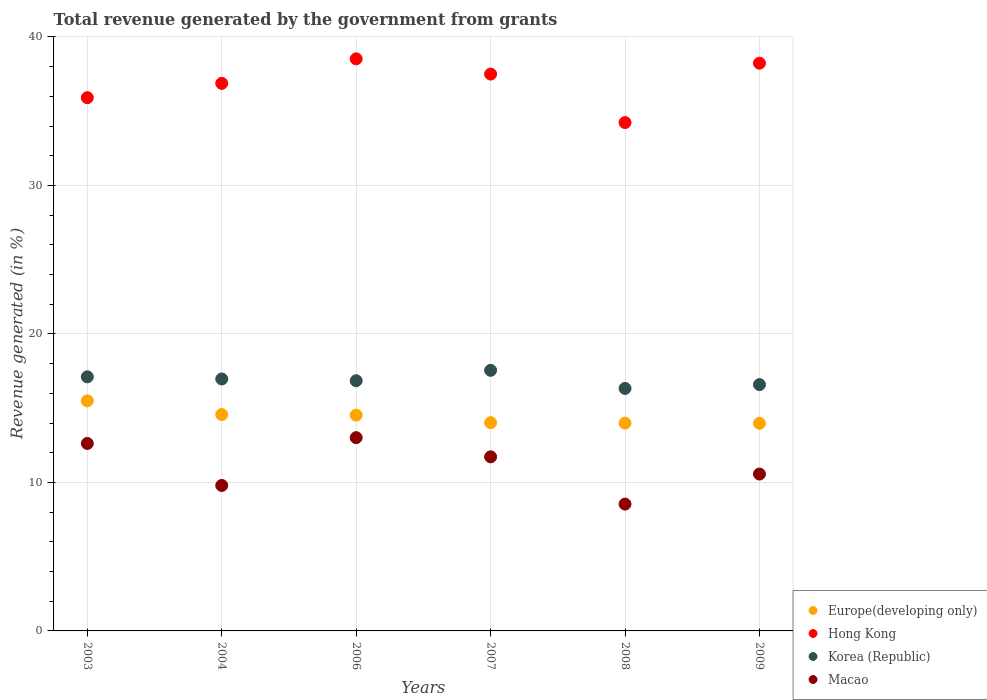What is the total revenue generated in Hong Kong in 2007?
Keep it short and to the point. 37.5. Across all years, what is the maximum total revenue generated in Europe(developing only)?
Your answer should be compact. 15.5. Across all years, what is the minimum total revenue generated in Korea (Republic)?
Ensure brevity in your answer.  16.33. In which year was the total revenue generated in Europe(developing only) maximum?
Your answer should be very brief. 2003. In which year was the total revenue generated in Europe(developing only) minimum?
Ensure brevity in your answer.  2009. What is the total total revenue generated in Europe(developing only) in the graph?
Your response must be concise. 86.59. What is the difference between the total revenue generated in Hong Kong in 2003 and that in 2008?
Keep it short and to the point. 1.67. What is the difference between the total revenue generated in Macao in 2004 and the total revenue generated in Europe(developing only) in 2009?
Your response must be concise. -4.19. What is the average total revenue generated in Macao per year?
Make the answer very short. 11.04. In the year 2009, what is the difference between the total revenue generated in Hong Kong and total revenue generated in Korea (Republic)?
Provide a succinct answer. 21.65. In how many years, is the total revenue generated in Macao greater than 12 %?
Offer a terse response. 2. What is the ratio of the total revenue generated in Korea (Republic) in 2004 to that in 2009?
Offer a terse response. 1.02. Is the total revenue generated in Europe(developing only) in 2003 less than that in 2004?
Offer a terse response. No. Is the difference between the total revenue generated in Hong Kong in 2003 and 2008 greater than the difference between the total revenue generated in Korea (Republic) in 2003 and 2008?
Offer a very short reply. Yes. What is the difference between the highest and the second highest total revenue generated in Europe(developing only)?
Your response must be concise. 0.93. What is the difference between the highest and the lowest total revenue generated in Europe(developing only)?
Keep it short and to the point. 1.51. In how many years, is the total revenue generated in Macao greater than the average total revenue generated in Macao taken over all years?
Make the answer very short. 3. Is the sum of the total revenue generated in Korea (Republic) in 2004 and 2007 greater than the maximum total revenue generated in Macao across all years?
Ensure brevity in your answer.  Yes. Is it the case that in every year, the sum of the total revenue generated in Macao and total revenue generated in Hong Kong  is greater than the total revenue generated in Korea (Republic)?
Keep it short and to the point. Yes. Does the total revenue generated in Hong Kong monotonically increase over the years?
Give a very brief answer. No. Is the total revenue generated in Hong Kong strictly greater than the total revenue generated in Europe(developing only) over the years?
Offer a terse response. Yes. Is the total revenue generated in Hong Kong strictly less than the total revenue generated in Europe(developing only) over the years?
Offer a terse response. No. How many dotlines are there?
Your response must be concise. 4. How many years are there in the graph?
Your answer should be very brief. 6. What is the difference between two consecutive major ticks on the Y-axis?
Provide a succinct answer. 10. Does the graph contain any zero values?
Offer a terse response. No. Does the graph contain grids?
Offer a very short reply. Yes. Where does the legend appear in the graph?
Offer a terse response. Bottom right. How many legend labels are there?
Offer a very short reply. 4. What is the title of the graph?
Your response must be concise. Total revenue generated by the government from grants. Does "Romania" appear as one of the legend labels in the graph?
Keep it short and to the point. No. What is the label or title of the X-axis?
Keep it short and to the point. Years. What is the label or title of the Y-axis?
Your answer should be compact. Revenue generated (in %). What is the Revenue generated (in %) in Europe(developing only) in 2003?
Provide a succinct answer. 15.5. What is the Revenue generated (in %) of Hong Kong in 2003?
Your response must be concise. 35.91. What is the Revenue generated (in %) of Korea (Republic) in 2003?
Provide a short and direct response. 17.11. What is the Revenue generated (in %) in Macao in 2003?
Make the answer very short. 12.62. What is the Revenue generated (in %) of Europe(developing only) in 2004?
Ensure brevity in your answer.  14.57. What is the Revenue generated (in %) of Hong Kong in 2004?
Provide a short and direct response. 36.87. What is the Revenue generated (in %) in Korea (Republic) in 2004?
Keep it short and to the point. 16.97. What is the Revenue generated (in %) in Macao in 2004?
Your answer should be compact. 9.8. What is the Revenue generated (in %) in Europe(developing only) in 2006?
Offer a terse response. 14.53. What is the Revenue generated (in %) of Hong Kong in 2006?
Offer a very short reply. 38.52. What is the Revenue generated (in %) in Korea (Republic) in 2006?
Ensure brevity in your answer.  16.85. What is the Revenue generated (in %) in Macao in 2006?
Your response must be concise. 13.02. What is the Revenue generated (in %) in Europe(developing only) in 2007?
Provide a short and direct response. 14.02. What is the Revenue generated (in %) in Hong Kong in 2007?
Keep it short and to the point. 37.5. What is the Revenue generated (in %) of Korea (Republic) in 2007?
Make the answer very short. 17.55. What is the Revenue generated (in %) in Macao in 2007?
Make the answer very short. 11.72. What is the Revenue generated (in %) of Europe(developing only) in 2008?
Offer a terse response. 13.99. What is the Revenue generated (in %) in Hong Kong in 2008?
Your response must be concise. 34.23. What is the Revenue generated (in %) of Korea (Republic) in 2008?
Give a very brief answer. 16.33. What is the Revenue generated (in %) in Macao in 2008?
Provide a succinct answer. 8.54. What is the Revenue generated (in %) in Europe(developing only) in 2009?
Your response must be concise. 13.98. What is the Revenue generated (in %) in Hong Kong in 2009?
Make the answer very short. 38.23. What is the Revenue generated (in %) of Korea (Republic) in 2009?
Provide a short and direct response. 16.59. What is the Revenue generated (in %) in Macao in 2009?
Offer a very short reply. 10.56. Across all years, what is the maximum Revenue generated (in %) in Europe(developing only)?
Offer a terse response. 15.5. Across all years, what is the maximum Revenue generated (in %) in Hong Kong?
Keep it short and to the point. 38.52. Across all years, what is the maximum Revenue generated (in %) in Korea (Republic)?
Provide a succinct answer. 17.55. Across all years, what is the maximum Revenue generated (in %) of Macao?
Offer a very short reply. 13.02. Across all years, what is the minimum Revenue generated (in %) of Europe(developing only)?
Offer a terse response. 13.98. Across all years, what is the minimum Revenue generated (in %) of Hong Kong?
Make the answer very short. 34.23. Across all years, what is the minimum Revenue generated (in %) of Korea (Republic)?
Give a very brief answer. 16.33. Across all years, what is the minimum Revenue generated (in %) of Macao?
Your response must be concise. 8.54. What is the total Revenue generated (in %) of Europe(developing only) in the graph?
Ensure brevity in your answer.  86.59. What is the total Revenue generated (in %) of Hong Kong in the graph?
Provide a succinct answer. 221.27. What is the total Revenue generated (in %) of Korea (Republic) in the graph?
Provide a succinct answer. 101.39. What is the total Revenue generated (in %) of Macao in the graph?
Your answer should be very brief. 66.26. What is the difference between the Revenue generated (in %) of Europe(developing only) in 2003 and that in 2004?
Offer a terse response. 0.93. What is the difference between the Revenue generated (in %) of Hong Kong in 2003 and that in 2004?
Give a very brief answer. -0.97. What is the difference between the Revenue generated (in %) of Korea (Republic) in 2003 and that in 2004?
Your answer should be compact. 0.14. What is the difference between the Revenue generated (in %) of Macao in 2003 and that in 2004?
Ensure brevity in your answer.  2.83. What is the difference between the Revenue generated (in %) in Europe(developing only) in 2003 and that in 2006?
Your answer should be very brief. 0.96. What is the difference between the Revenue generated (in %) in Hong Kong in 2003 and that in 2006?
Your answer should be compact. -2.62. What is the difference between the Revenue generated (in %) in Korea (Republic) in 2003 and that in 2006?
Provide a succinct answer. 0.26. What is the difference between the Revenue generated (in %) of Macao in 2003 and that in 2006?
Provide a short and direct response. -0.39. What is the difference between the Revenue generated (in %) of Europe(developing only) in 2003 and that in 2007?
Your response must be concise. 1.47. What is the difference between the Revenue generated (in %) of Hong Kong in 2003 and that in 2007?
Keep it short and to the point. -1.59. What is the difference between the Revenue generated (in %) of Korea (Republic) in 2003 and that in 2007?
Make the answer very short. -0.44. What is the difference between the Revenue generated (in %) of Macao in 2003 and that in 2007?
Ensure brevity in your answer.  0.9. What is the difference between the Revenue generated (in %) of Europe(developing only) in 2003 and that in 2008?
Your answer should be compact. 1.5. What is the difference between the Revenue generated (in %) of Hong Kong in 2003 and that in 2008?
Make the answer very short. 1.67. What is the difference between the Revenue generated (in %) in Korea (Republic) in 2003 and that in 2008?
Keep it short and to the point. 0.78. What is the difference between the Revenue generated (in %) of Macao in 2003 and that in 2008?
Ensure brevity in your answer.  4.08. What is the difference between the Revenue generated (in %) of Europe(developing only) in 2003 and that in 2009?
Make the answer very short. 1.51. What is the difference between the Revenue generated (in %) of Hong Kong in 2003 and that in 2009?
Your response must be concise. -2.32. What is the difference between the Revenue generated (in %) of Korea (Republic) in 2003 and that in 2009?
Ensure brevity in your answer.  0.52. What is the difference between the Revenue generated (in %) of Macao in 2003 and that in 2009?
Give a very brief answer. 2.06. What is the difference between the Revenue generated (in %) in Europe(developing only) in 2004 and that in 2006?
Your answer should be very brief. 0.04. What is the difference between the Revenue generated (in %) in Hong Kong in 2004 and that in 2006?
Offer a very short reply. -1.65. What is the difference between the Revenue generated (in %) in Korea (Republic) in 2004 and that in 2006?
Your answer should be compact. 0.12. What is the difference between the Revenue generated (in %) in Macao in 2004 and that in 2006?
Offer a very short reply. -3.22. What is the difference between the Revenue generated (in %) of Europe(developing only) in 2004 and that in 2007?
Offer a terse response. 0.54. What is the difference between the Revenue generated (in %) of Hong Kong in 2004 and that in 2007?
Your answer should be compact. -0.63. What is the difference between the Revenue generated (in %) of Korea (Republic) in 2004 and that in 2007?
Keep it short and to the point. -0.58. What is the difference between the Revenue generated (in %) of Macao in 2004 and that in 2007?
Ensure brevity in your answer.  -1.93. What is the difference between the Revenue generated (in %) in Europe(developing only) in 2004 and that in 2008?
Keep it short and to the point. 0.58. What is the difference between the Revenue generated (in %) of Hong Kong in 2004 and that in 2008?
Offer a very short reply. 2.64. What is the difference between the Revenue generated (in %) in Korea (Republic) in 2004 and that in 2008?
Your response must be concise. 0.64. What is the difference between the Revenue generated (in %) in Macao in 2004 and that in 2008?
Your answer should be very brief. 1.26. What is the difference between the Revenue generated (in %) in Europe(developing only) in 2004 and that in 2009?
Give a very brief answer. 0.59. What is the difference between the Revenue generated (in %) of Hong Kong in 2004 and that in 2009?
Provide a succinct answer. -1.36. What is the difference between the Revenue generated (in %) in Korea (Republic) in 2004 and that in 2009?
Offer a terse response. 0.38. What is the difference between the Revenue generated (in %) in Macao in 2004 and that in 2009?
Make the answer very short. -0.77. What is the difference between the Revenue generated (in %) of Europe(developing only) in 2006 and that in 2007?
Provide a short and direct response. 0.51. What is the difference between the Revenue generated (in %) in Hong Kong in 2006 and that in 2007?
Your response must be concise. 1.03. What is the difference between the Revenue generated (in %) of Korea (Republic) in 2006 and that in 2007?
Make the answer very short. -0.7. What is the difference between the Revenue generated (in %) of Macao in 2006 and that in 2007?
Provide a succinct answer. 1.29. What is the difference between the Revenue generated (in %) of Europe(developing only) in 2006 and that in 2008?
Provide a short and direct response. 0.54. What is the difference between the Revenue generated (in %) in Hong Kong in 2006 and that in 2008?
Offer a terse response. 4.29. What is the difference between the Revenue generated (in %) of Korea (Republic) in 2006 and that in 2008?
Make the answer very short. 0.52. What is the difference between the Revenue generated (in %) of Macao in 2006 and that in 2008?
Ensure brevity in your answer.  4.47. What is the difference between the Revenue generated (in %) in Europe(developing only) in 2006 and that in 2009?
Offer a very short reply. 0.55. What is the difference between the Revenue generated (in %) in Hong Kong in 2006 and that in 2009?
Ensure brevity in your answer.  0.29. What is the difference between the Revenue generated (in %) in Korea (Republic) in 2006 and that in 2009?
Offer a terse response. 0.26. What is the difference between the Revenue generated (in %) of Macao in 2006 and that in 2009?
Keep it short and to the point. 2.45. What is the difference between the Revenue generated (in %) of Europe(developing only) in 2007 and that in 2008?
Your answer should be compact. 0.03. What is the difference between the Revenue generated (in %) of Hong Kong in 2007 and that in 2008?
Your response must be concise. 3.27. What is the difference between the Revenue generated (in %) of Korea (Republic) in 2007 and that in 2008?
Make the answer very short. 1.22. What is the difference between the Revenue generated (in %) of Macao in 2007 and that in 2008?
Make the answer very short. 3.18. What is the difference between the Revenue generated (in %) of Europe(developing only) in 2007 and that in 2009?
Offer a terse response. 0.04. What is the difference between the Revenue generated (in %) in Hong Kong in 2007 and that in 2009?
Your answer should be compact. -0.73. What is the difference between the Revenue generated (in %) in Korea (Republic) in 2007 and that in 2009?
Ensure brevity in your answer.  0.96. What is the difference between the Revenue generated (in %) in Macao in 2007 and that in 2009?
Provide a short and direct response. 1.16. What is the difference between the Revenue generated (in %) of Europe(developing only) in 2008 and that in 2009?
Make the answer very short. 0.01. What is the difference between the Revenue generated (in %) of Hong Kong in 2008 and that in 2009?
Make the answer very short. -4. What is the difference between the Revenue generated (in %) in Korea (Republic) in 2008 and that in 2009?
Provide a succinct answer. -0.26. What is the difference between the Revenue generated (in %) of Macao in 2008 and that in 2009?
Your answer should be very brief. -2.02. What is the difference between the Revenue generated (in %) of Europe(developing only) in 2003 and the Revenue generated (in %) of Hong Kong in 2004?
Your response must be concise. -21.38. What is the difference between the Revenue generated (in %) in Europe(developing only) in 2003 and the Revenue generated (in %) in Korea (Republic) in 2004?
Offer a terse response. -1.47. What is the difference between the Revenue generated (in %) of Europe(developing only) in 2003 and the Revenue generated (in %) of Macao in 2004?
Offer a very short reply. 5.7. What is the difference between the Revenue generated (in %) of Hong Kong in 2003 and the Revenue generated (in %) of Korea (Republic) in 2004?
Ensure brevity in your answer.  18.94. What is the difference between the Revenue generated (in %) of Hong Kong in 2003 and the Revenue generated (in %) of Macao in 2004?
Provide a short and direct response. 26.11. What is the difference between the Revenue generated (in %) of Korea (Republic) in 2003 and the Revenue generated (in %) of Macao in 2004?
Your response must be concise. 7.31. What is the difference between the Revenue generated (in %) of Europe(developing only) in 2003 and the Revenue generated (in %) of Hong Kong in 2006?
Offer a terse response. -23.03. What is the difference between the Revenue generated (in %) in Europe(developing only) in 2003 and the Revenue generated (in %) in Korea (Republic) in 2006?
Your answer should be very brief. -1.35. What is the difference between the Revenue generated (in %) in Europe(developing only) in 2003 and the Revenue generated (in %) in Macao in 2006?
Give a very brief answer. 2.48. What is the difference between the Revenue generated (in %) in Hong Kong in 2003 and the Revenue generated (in %) in Korea (Republic) in 2006?
Offer a terse response. 19.06. What is the difference between the Revenue generated (in %) of Hong Kong in 2003 and the Revenue generated (in %) of Macao in 2006?
Offer a terse response. 22.89. What is the difference between the Revenue generated (in %) in Korea (Republic) in 2003 and the Revenue generated (in %) in Macao in 2006?
Offer a terse response. 4.1. What is the difference between the Revenue generated (in %) of Europe(developing only) in 2003 and the Revenue generated (in %) of Hong Kong in 2007?
Your answer should be very brief. -22. What is the difference between the Revenue generated (in %) of Europe(developing only) in 2003 and the Revenue generated (in %) of Korea (Republic) in 2007?
Your response must be concise. -2.05. What is the difference between the Revenue generated (in %) of Europe(developing only) in 2003 and the Revenue generated (in %) of Macao in 2007?
Keep it short and to the point. 3.77. What is the difference between the Revenue generated (in %) of Hong Kong in 2003 and the Revenue generated (in %) of Korea (Republic) in 2007?
Your answer should be compact. 18.36. What is the difference between the Revenue generated (in %) in Hong Kong in 2003 and the Revenue generated (in %) in Macao in 2007?
Offer a very short reply. 24.18. What is the difference between the Revenue generated (in %) in Korea (Republic) in 2003 and the Revenue generated (in %) in Macao in 2007?
Your answer should be compact. 5.39. What is the difference between the Revenue generated (in %) in Europe(developing only) in 2003 and the Revenue generated (in %) in Hong Kong in 2008?
Provide a succinct answer. -18.74. What is the difference between the Revenue generated (in %) of Europe(developing only) in 2003 and the Revenue generated (in %) of Korea (Republic) in 2008?
Offer a very short reply. -0.83. What is the difference between the Revenue generated (in %) in Europe(developing only) in 2003 and the Revenue generated (in %) in Macao in 2008?
Offer a terse response. 6.95. What is the difference between the Revenue generated (in %) of Hong Kong in 2003 and the Revenue generated (in %) of Korea (Republic) in 2008?
Your response must be concise. 19.58. What is the difference between the Revenue generated (in %) of Hong Kong in 2003 and the Revenue generated (in %) of Macao in 2008?
Offer a terse response. 27.37. What is the difference between the Revenue generated (in %) of Korea (Republic) in 2003 and the Revenue generated (in %) of Macao in 2008?
Provide a succinct answer. 8.57. What is the difference between the Revenue generated (in %) in Europe(developing only) in 2003 and the Revenue generated (in %) in Hong Kong in 2009?
Keep it short and to the point. -22.74. What is the difference between the Revenue generated (in %) of Europe(developing only) in 2003 and the Revenue generated (in %) of Korea (Republic) in 2009?
Give a very brief answer. -1.09. What is the difference between the Revenue generated (in %) of Europe(developing only) in 2003 and the Revenue generated (in %) of Macao in 2009?
Give a very brief answer. 4.93. What is the difference between the Revenue generated (in %) of Hong Kong in 2003 and the Revenue generated (in %) of Korea (Republic) in 2009?
Provide a short and direct response. 19.32. What is the difference between the Revenue generated (in %) in Hong Kong in 2003 and the Revenue generated (in %) in Macao in 2009?
Make the answer very short. 25.34. What is the difference between the Revenue generated (in %) in Korea (Republic) in 2003 and the Revenue generated (in %) in Macao in 2009?
Offer a very short reply. 6.55. What is the difference between the Revenue generated (in %) of Europe(developing only) in 2004 and the Revenue generated (in %) of Hong Kong in 2006?
Make the answer very short. -23.96. What is the difference between the Revenue generated (in %) of Europe(developing only) in 2004 and the Revenue generated (in %) of Korea (Republic) in 2006?
Your answer should be very brief. -2.28. What is the difference between the Revenue generated (in %) in Europe(developing only) in 2004 and the Revenue generated (in %) in Macao in 2006?
Offer a terse response. 1.55. What is the difference between the Revenue generated (in %) of Hong Kong in 2004 and the Revenue generated (in %) of Korea (Republic) in 2006?
Offer a very short reply. 20.03. What is the difference between the Revenue generated (in %) of Hong Kong in 2004 and the Revenue generated (in %) of Macao in 2006?
Ensure brevity in your answer.  23.86. What is the difference between the Revenue generated (in %) in Korea (Republic) in 2004 and the Revenue generated (in %) in Macao in 2006?
Provide a succinct answer. 3.95. What is the difference between the Revenue generated (in %) in Europe(developing only) in 2004 and the Revenue generated (in %) in Hong Kong in 2007?
Your response must be concise. -22.93. What is the difference between the Revenue generated (in %) in Europe(developing only) in 2004 and the Revenue generated (in %) in Korea (Republic) in 2007?
Provide a succinct answer. -2.98. What is the difference between the Revenue generated (in %) in Europe(developing only) in 2004 and the Revenue generated (in %) in Macao in 2007?
Give a very brief answer. 2.84. What is the difference between the Revenue generated (in %) of Hong Kong in 2004 and the Revenue generated (in %) of Korea (Republic) in 2007?
Provide a short and direct response. 19.32. What is the difference between the Revenue generated (in %) of Hong Kong in 2004 and the Revenue generated (in %) of Macao in 2007?
Provide a succinct answer. 25.15. What is the difference between the Revenue generated (in %) in Korea (Republic) in 2004 and the Revenue generated (in %) in Macao in 2007?
Keep it short and to the point. 5.24. What is the difference between the Revenue generated (in %) in Europe(developing only) in 2004 and the Revenue generated (in %) in Hong Kong in 2008?
Offer a terse response. -19.67. What is the difference between the Revenue generated (in %) of Europe(developing only) in 2004 and the Revenue generated (in %) of Korea (Republic) in 2008?
Your answer should be very brief. -1.76. What is the difference between the Revenue generated (in %) in Europe(developing only) in 2004 and the Revenue generated (in %) in Macao in 2008?
Your answer should be very brief. 6.03. What is the difference between the Revenue generated (in %) in Hong Kong in 2004 and the Revenue generated (in %) in Korea (Republic) in 2008?
Provide a short and direct response. 20.54. What is the difference between the Revenue generated (in %) in Hong Kong in 2004 and the Revenue generated (in %) in Macao in 2008?
Provide a short and direct response. 28.33. What is the difference between the Revenue generated (in %) of Korea (Republic) in 2004 and the Revenue generated (in %) of Macao in 2008?
Offer a very short reply. 8.43. What is the difference between the Revenue generated (in %) in Europe(developing only) in 2004 and the Revenue generated (in %) in Hong Kong in 2009?
Your answer should be very brief. -23.66. What is the difference between the Revenue generated (in %) in Europe(developing only) in 2004 and the Revenue generated (in %) in Korea (Republic) in 2009?
Ensure brevity in your answer.  -2.02. What is the difference between the Revenue generated (in %) of Europe(developing only) in 2004 and the Revenue generated (in %) of Macao in 2009?
Give a very brief answer. 4. What is the difference between the Revenue generated (in %) of Hong Kong in 2004 and the Revenue generated (in %) of Korea (Republic) in 2009?
Your answer should be very brief. 20.29. What is the difference between the Revenue generated (in %) in Hong Kong in 2004 and the Revenue generated (in %) in Macao in 2009?
Make the answer very short. 26.31. What is the difference between the Revenue generated (in %) of Korea (Republic) in 2004 and the Revenue generated (in %) of Macao in 2009?
Provide a succinct answer. 6.4. What is the difference between the Revenue generated (in %) of Europe(developing only) in 2006 and the Revenue generated (in %) of Hong Kong in 2007?
Keep it short and to the point. -22.97. What is the difference between the Revenue generated (in %) in Europe(developing only) in 2006 and the Revenue generated (in %) in Korea (Republic) in 2007?
Provide a short and direct response. -3.02. What is the difference between the Revenue generated (in %) of Europe(developing only) in 2006 and the Revenue generated (in %) of Macao in 2007?
Offer a terse response. 2.81. What is the difference between the Revenue generated (in %) in Hong Kong in 2006 and the Revenue generated (in %) in Korea (Republic) in 2007?
Keep it short and to the point. 20.98. What is the difference between the Revenue generated (in %) of Hong Kong in 2006 and the Revenue generated (in %) of Macao in 2007?
Provide a succinct answer. 26.8. What is the difference between the Revenue generated (in %) of Korea (Republic) in 2006 and the Revenue generated (in %) of Macao in 2007?
Provide a succinct answer. 5.12. What is the difference between the Revenue generated (in %) of Europe(developing only) in 2006 and the Revenue generated (in %) of Hong Kong in 2008?
Offer a terse response. -19.7. What is the difference between the Revenue generated (in %) in Europe(developing only) in 2006 and the Revenue generated (in %) in Korea (Republic) in 2008?
Provide a succinct answer. -1.8. What is the difference between the Revenue generated (in %) of Europe(developing only) in 2006 and the Revenue generated (in %) of Macao in 2008?
Give a very brief answer. 5.99. What is the difference between the Revenue generated (in %) of Hong Kong in 2006 and the Revenue generated (in %) of Korea (Republic) in 2008?
Offer a terse response. 22.2. What is the difference between the Revenue generated (in %) in Hong Kong in 2006 and the Revenue generated (in %) in Macao in 2008?
Make the answer very short. 29.98. What is the difference between the Revenue generated (in %) in Korea (Republic) in 2006 and the Revenue generated (in %) in Macao in 2008?
Keep it short and to the point. 8.31. What is the difference between the Revenue generated (in %) of Europe(developing only) in 2006 and the Revenue generated (in %) of Hong Kong in 2009?
Offer a terse response. -23.7. What is the difference between the Revenue generated (in %) of Europe(developing only) in 2006 and the Revenue generated (in %) of Korea (Republic) in 2009?
Offer a terse response. -2.06. What is the difference between the Revenue generated (in %) of Europe(developing only) in 2006 and the Revenue generated (in %) of Macao in 2009?
Offer a very short reply. 3.97. What is the difference between the Revenue generated (in %) in Hong Kong in 2006 and the Revenue generated (in %) in Korea (Republic) in 2009?
Provide a succinct answer. 21.94. What is the difference between the Revenue generated (in %) in Hong Kong in 2006 and the Revenue generated (in %) in Macao in 2009?
Your answer should be very brief. 27.96. What is the difference between the Revenue generated (in %) in Korea (Republic) in 2006 and the Revenue generated (in %) in Macao in 2009?
Your answer should be very brief. 6.28. What is the difference between the Revenue generated (in %) of Europe(developing only) in 2007 and the Revenue generated (in %) of Hong Kong in 2008?
Keep it short and to the point. -20.21. What is the difference between the Revenue generated (in %) in Europe(developing only) in 2007 and the Revenue generated (in %) in Korea (Republic) in 2008?
Your answer should be compact. -2.31. What is the difference between the Revenue generated (in %) of Europe(developing only) in 2007 and the Revenue generated (in %) of Macao in 2008?
Give a very brief answer. 5.48. What is the difference between the Revenue generated (in %) of Hong Kong in 2007 and the Revenue generated (in %) of Korea (Republic) in 2008?
Your answer should be very brief. 21.17. What is the difference between the Revenue generated (in %) in Hong Kong in 2007 and the Revenue generated (in %) in Macao in 2008?
Your answer should be very brief. 28.96. What is the difference between the Revenue generated (in %) in Korea (Republic) in 2007 and the Revenue generated (in %) in Macao in 2008?
Provide a succinct answer. 9.01. What is the difference between the Revenue generated (in %) of Europe(developing only) in 2007 and the Revenue generated (in %) of Hong Kong in 2009?
Ensure brevity in your answer.  -24.21. What is the difference between the Revenue generated (in %) of Europe(developing only) in 2007 and the Revenue generated (in %) of Korea (Republic) in 2009?
Provide a short and direct response. -2.56. What is the difference between the Revenue generated (in %) in Europe(developing only) in 2007 and the Revenue generated (in %) in Macao in 2009?
Provide a succinct answer. 3.46. What is the difference between the Revenue generated (in %) of Hong Kong in 2007 and the Revenue generated (in %) of Korea (Republic) in 2009?
Provide a short and direct response. 20.91. What is the difference between the Revenue generated (in %) in Hong Kong in 2007 and the Revenue generated (in %) in Macao in 2009?
Ensure brevity in your answer.  26.93. What is the difference between the Revenue generated (in %) in Korea (Republic) in 2007 and the Revenue generated (in %) in Macao in 2009?
Give a very brief answer. 6.98. What is the difference between the Revenue generated (in %) in Europe(developing only) in 2008 and the Revenue generated (in %) in Hong Kong in 2009?
Your answer should be compact. -24.24. What is the difference between the Revenue generated (in %) of Europe(developing only) in 2008 and the Revenue generated (in %) of Korea (Republic) in 2009?
Offer a terse response. -2.59. What is the difference between the Revenue generated (in %) in Europe(developing only) in 2008 and the Revenue generated (in %) in Macao in 2009?
Provide a succinct answer. 3.43. What is the difference between the Revenue generated (in %) in Hong Kong in 2008 and the Revenue generated (in %) in Korea (Republic) in 2009?
Your response must be concise. 17.65. What is the difference between the Revenue generated (in %) of Hong Kong in 2008 and the Revenue generated (in %) of Macao in 2009?
Provide a succinct answer. 23.67. What is the difference between the Revenue generated (in %) in Korea (Republic) in 2008 and the Revenue generated (in %) in Macao in 2009?
Give a very brief answer. 5.76. What is the average Revenue generated (in %) in Europe(developing only) per year?
Provide a short and direct response. 14.43. What is the average Revenue generated (in %) of Hong Kong per year?
Offer a terse response. 36.88. What is the average Revenue generated (in %) of Korea (Republic) per year?
Provide a succinct answer. 16.9. What is the average Revenue generated (in %) of Macao per year?
Ensure brevity in your answer.  11.04. In the year 2003, what is the difference between the Revenue generated (in %) in Europe(developing only) and Revenue generated (in %) in Hong Kong?
Offer a terse response. -20.41. In the year 2003, what is the difference between the Revenue generated (in %) of Europe(developing only) and Revenue generated (in %) of Korea (Republic)?
Your answer should be compact. -1.62. In the year 2003, what is the difference between the Revenue generated (in %) in Europe(developing only) and Revenue generated (in %) in Macao?
Provide a succinct answer. 2.87. In the year 2003, what is the difference between the Revenue generated (in %) in Hong Kong and Revenue generated (in %) in Korea (Republic)?
Make the answer very short. 18.8. In the year 2003, what is the difference between the Revenue generated (in %) of Hong Kong and Revenue generated (in %) of Macao?
Provide a succinct answer. 23.28. In the year 2003, what is the difference between the Revenue generated (in %) in Korea (Republic) and Revenue generated (in %) in Macao?
Provide a succinct answer. 4.49. In the year 2004, what is the difference between the Revenue generated (in %) in Europe(developing only) and Revenue generated (in %) in Hong Kong?
Offer a very short reply. -22.31. In the year 2004, what is the difference between the Revenue generated (in %) in Europe(developing only) and Revenue generated (in %) in Korea (Republic)?
Give a very brief answer. -2.4. In the year 2004, what is the difference between the Revenue generated (in %) of Europe(developing only) and Revenue generated (in %) of Macao?
Your response must be concise. 4.77. In the year 2004, what is the difference between the Revenue generated (in %) in Hong Kong and Revenue generated (in %) in Korea (Republic)?
Ensure brevity in your answer.  19.91. In the year 2004, what is the difference between the Revenue generated (in %) of Hong Kong and Revenue generated (in %) of Macao?
Give a very brief answer. 27.08. In the year 2004, what is the difference between the Revenue generated (in %) of Korea (Republic) and Revenue generated (in %) of Macao?
Provide a succinct answer. 7.17. In the year 2006, what is the difference between the Revenue generated (in %) in Europe(developing only) and Revenue generated (in %) in Hong Kong?
Provide a succinct answer. -23.99. In the year 2006, what is the difference between the Revenue generated (in %) of Europe(developing only) and Revenue generated (in %) of Korea (Republic)?
Your answer should be very brief. -2.32. In the year 2006, what is the difference between the Revenue generated (in %) in Europe(developing only) and Revenue generated (in %) in Macao?
Offer a terse response. 1.52. In the year 2006, what is the difference between the Revenue generated (in %) in Hong Kong and Revenue generated (in %) in Korea (Republic)?
Make the answer very short. 21.68. In the year 2006, what is the difference between the Revenue generated (in %) in Hong Kong and Revenue generated (in %) in Macao?
Offer a terse response. 25.51. In the year 2006, what is the difference between the Revenue generated (in %) of Korea (Republic) and Revenue generated (in %) of Macao?
Provide a short and direct response. 3.83. In the year 2007, what is the difference between the Revenue generated (in %) of Europe(developing only) and Revenue generated (in %) of Hong Kong?
Give a very brief answer. -23.48. In the year 2007, what is the difference between the Revenue generated (in %) in Europe(developing only) and Revenue generated (in %) in Korea (Republic)?
Keep it short and to the point. -3.53. In the year 2007, what is the difference between the Revenue generated (in %) in Europe(developing only) and Revenue generated (in %) in Macao?
Provide a succinct answer. 2.3. In the year 2007, what is the difference between the Revenue generated (in %) of Hong Kong and Revenue generated (in %) of Korea (Republic)?
Provide a short and direct response. 19.95. In the year 2007, what is the difference between the Revenue generated (in %) in Hong Kong and Revenue generated (in %) in Macao?
Make the answer very short. 25.78. In the year 2007, what is the difference between the Revenue generated (in %) of Korea (Republic) and Revenue generated (in %) of Macao?
Provide a succinct answer. 5.83. In the year 2008, what is the difference between the Revenue generated (in %) in Europe(developing only) and Revenue generated (in %) in Hong Kong?
Offer a terse response. -20.24. In the year 2008, what is the difference between the Revenue generated (in %) in Europe(developing only) and Revenue generated (in %) in Korea (Republic)?
Give a very brief answer. -2.34. In the year 2008, what is the difference between the Revenue generated (in %) in Europe(developing only) and Revenue generated (in %) in Macao?
Your answer should be very brief. 5.45. In the year 2008, what is the difference between the Revenue generated (in %) of Hong Kong and Revenue generated (in %) of Korea (Republic)?
Give a very brief answer. 17.91. In the year 2008, what is the difference between the Revenue generated (in %) in Hong Kong and Revenue generated (in %) in Macao?
Your response must be concise. 25.69. In the year 2008, what is the difference between the Revenue generated (in %) in Korea (Republic) and Revenue generated (in %) in Macao?
Make the answer very short. 7.79. In the year 2009, what is the difference between the Revenue generated (in %) in Europe(developing only) and Revenue generated (in %) in Hong Kong?
Offer a terse response. -24.25. In the year 2009, what is the difference between the Revenue generated (in %) in Europe(developing only) and Revenue generated (in %) in Korea (Republic)?
Make the answer very short. -2.61. In the year 2009, what is the difference between the Revenue generated (in %) of Europe(developing only) and Revenue generated (in %) of Macao?
Provide a succinct answer. 3.42. In the year 2009, what is the difference between the Revenue generated (in %) of Hong Kong and Revenue generated (in %) of Korea (Republic)?
Make the answer very short. 21.65. In the year 2009, what is the difference between the Revenue generated (in %) in Hong Kong and Revenue generated (in %) in Macao?
Your response must be concise. 27.67. In the year 2009, what is the difference between the Revenue generated (in %) in Korea (Republic) and Revenue generated (in %) in Macao?
Your answer should be very brief. 6.02. What is the ratio of the Revenue generated (in %) in Europe(developing only) in 2003 to that in 2004?
Keep it short and to the point. 1.06. What is the ratio of the Revenue generated (in %) of Hong Kong in 2003 to that in 2004?
Provide a succinct answer. 0.97. What is the ratio of the Revenue generated (in %) in Korea (Republic) in 2003 to that in 2004?
Provide a succinct answer. 1.01. What is the ratio of the Revenue generated (in %) of Macao in 2003 to that in 2004?
Make the answer very short. 1.29. What is the ratio of the Revenue generated (in %) in Europe(developing only) in 2003 to that in 2006?
Provide a succinct answer. 1.07. What is the ratio of the Revenue generated (in %) of Hong Kong in 2003 to that in 2006?
Offer a very short reply. 0.93. What is the ratio of the Revenue generated (in %) in Korea (Republic) in 2003 to that in 2006?
Give a very brief answer. 1.02. What is the ratio of the Revenue generated (in %) of Europe(developing only) in 2003 to that in 2007?
Your answer should be very brief. 1.1. What is the ratio of the Revenue generated (in %) in Hong Kong in 2003 to that in 2007?
Your response must be concise. 0.96. What is the ratio of the Revenue generated (in %) in Korea (Republic) in 2003 to that in 2007?
Offer a very short reply. 0.97. What is the ratio of the Revenue generated (in %) in Macao in 2003 to that in 2007?
Offer a very short reply. 1.08. What is the ratio of the Revenue generated (in %) in Europe(developing only) in 2003 to that in 2008?
Offer a terse response. 1.11. What is the ratio of the Revenue generated (in %) in Hong Kong in 2003 to that in 2008?
Give a very brief answer. 1.05. What is the ratio of the Revenue generated (in %) in Korea (Republic) in 2003 to that in 2008?
Your response must be concise. 1.05. What is the ratio of the Revenue generated (in %) of Macao in 2003 to that in 2008?
Provide a short and direct response. 1.48. What is the ratio of the Revenue generated (in %) of Europe(developing only) in 2003 to that in 2009?
Offer a very short reply. 1.11. What is the ratio of the Revenue generated (in %) in Hong Kong in 2003 to that in 2009?
Offer a very short reply. 0.94. What is the ratio of the Revenue generated (in %) in Korea (Republic) in 2003 to that in 2009?
Give a very brief answer. 1.03. What is the ratio of the Revenue generated (in %) of Macao in 2003 to that in 2009?
Make the answer very short. 1.2. What is the ratio of the Revenue generated (in %) of Hong Kong in 2004 to that in 2006?
Offer a terse response. 0.96. What is the ratio of the Revenue generated (in %) in Macao in 2004 to that in 2006?
Provide a succinct answer. 0.75. What is the ratio of the Revenue generated (in %) of Europe(developing only) in 2004 to that in 2007?
Your answer should be very brief. 1.04. What is the ratio of the Revenue generated (in %) in Hong Kong in 2004 to that in 2007?
Offer a terse response. 0.98. What is the ratio of the Revenue generated (in %) of Korea (Republic) in 2004 to that in 2007?
Give a very brief answer. 0.97. What is the ratio of the Revenue generated (in %) in Macao in 2004 to that in 2007?
Offer a terse response. 0.84. What is the ratio of the Revenue generated (in %) in Europe(developing only) in 2004 to that in 2008?
Provide a short and direct response. 1.04. What is the ratio of the Revenue generated (in %) of Hong Kong in 2004 to that in 2008?
Provide a succinct answer. 1.08. What is the ratio of the Revenue generated (in %) in Korea (Republic) in 2004 to that in 2008?
Provide a succinct answer. 1.04. What is the ratio of the Revenue generated (in %) of Macao in 2004 to that in 2008?
Keep it short and to the point. 1.15. What is the ratio of the Revenue generated (in %) of Europe(developing only) in 2004 to that in 2009?
Ensure brevity in your answer.  1.04. What is the ratio of the Revenue generated (in %) of Hong Kong in 2004 to that in 2009?
Ensure brevity in your answer.  0.96. What is the ratio of the Revenue generated (in %) in Korea (Republic) in 2004 to that in 2009?
Make the answer very short. 1.02. What is the ratio of the Revenue generated (in %) of Macao in 2004 to that in 2009?
Your answer should be compact. 0.93. What is the ratio of the Revenue generated (in %) in Europe(developing only) in 2006 to that in 2007?
Provide a succinct answer. 1.04. What is the ratio of the Revenue generated (in %) in Hong Kong in 2006 to that in 2007?
Your answer should be very brief. 1.03. What is the ratio of the Revenue generated (in %) of Korea (Republic) in 2006 to that in 2007?
Ensure brevity in your answer.  0.96. What is the ratio of the Revenue generated (in %) of Macao in 2006 to that in 2007?
Provide a succinct answer. 1.11. What is the ratio of the Revenue generated (in %) in Hong Kong in 2006 to that in 2008?
Keep it short and to the point. 1.13. What is the ratio of the Revenue generated (in %) of Korea (Republic) in 2006 to that in 2008?
Provide a short and direct response. 1.03. What is the ratio of the Revenue generated (in %) in Macao in 2006 to that in 2008?
Provide a succinct answer. 1.52. What is the ratio of the Revenue generated (in %) of Europe(developing only) in 2006 to that in 2009?
Offer a very short reply. 1.04. What is the ratio of the Revenue generated (in %) of Hong Kong in 2006 to that in 2009?
Provide a succinct answer. 1.01. What is the ratio of the Revenue generated (in %) in Korea (Republic) in 2006 to that in 2009?
Give a very brief answer. 1.02. What is the ratio of the Revenue generated (in %) in Macao in 2006 to that in 2009?
Ensure brevity in your answer.  1.23. What is the ratio of the Revenue generated (in %) of Hong Kong in 2007 to that in 2008?
Your answer should be very brief. 1.1. What is the ratio of the Revenue generated (in %) in Korea (Republic) in 2007 to that in 2008?
Your answer should be very brief. 1.07. What is the ratio of the Revenue generated (in %) of Macao in 2007 to that in 2008?
Provide a succinct answer. 1.37. What is the ratio of the Revenue generated (in %) of Europe(developing only) in 2007 to that in 2009?
Provide a succinct answer. 1. What is the ratio of the Revenue generated (in %) of Hong Kong in 2007 to that in 2009?
Offer a very short reply. 0.98. What is the ratio of the Revenue generated (in %) in Korea (Republic) in 2007 to that in 2009?
Offer a very short reply. 1.06. What is the ratio of the Revenue generated (in %) in Macao in 2007 to that in 2009?
Provide a short and direct response. 1.11. What is the ratio of the Revenue generated (in %) of Hong Kong in 2008 to that in 2009?
Provide a succinct answer. 0.9. What is the ratio of the Revenue generated (in %) of Korea (Republic) in 2008 to that in 2009?
Give a very brief answer. 0.98. What is the ratio of the Revenue generated (in %) of Macao in 2008 to that in 2009?
Your response must be concise. 0.81. What is the difference between the highest and the second highest Revenue generated (in %) in Europe(developing only)?
Provide a short and direct response. 0.93. What is the difference between the highest and the second highest Revenue generated (in %) in Hong Kong?
Your response must be concise. 0.29. What is the difference between the highest and the second highest Revenue generated (in %) in Korea (Republic)?
Provide a succinct answer. 0.44. What is the difference between the highest and the second highest Revenue generated (in %) of Macao?
Ensure brevity in your answer.  0.39. What is the difference between the highest and the lowest Revenue generated (in %) of Europe(developing only)?
Your answer should be very brief. 1.51. What is the difference between the highest and the lowest Revenue generated (in %) of Hong Kong?
Make the answer very short. 4.29. What is the difference between the highest and the lowest Revenue generated (in %) of Korea (Republic)?
Give a very brief answer. 1.22. What is the difference between the highest and the lowest Revenue generated (in %) in Macao?
Provide a short and direct response. 4.47. 